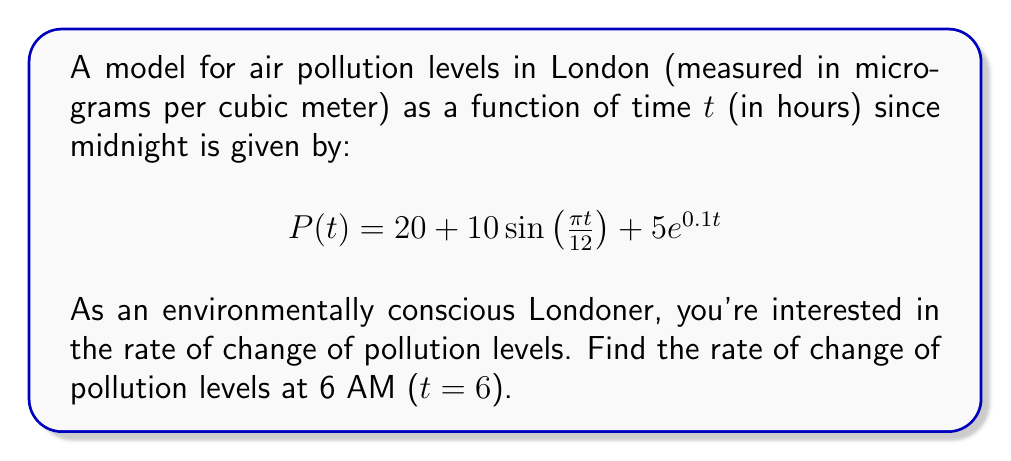Teach me how to tackle this problem. To find the rate of change of pollution levels at 6 AM, we need to find the derivative of P(t) and evaluate it at t = 6.

Step 1: Find P'(t) using the sum rule and chain rule.

$$P'(t) = \frac{d}{dt}[20 + 10\sin(\frac{\pi t}{12}) + 5e^{0.1t}]$$
$$P'(t) = 0 + 10\cos(\frac{\pi t}{12}) \cdot \frac{\pi}{12} + 5 \cdot 0.1e^{0.1t}$$
$$P'(t) = \frac{5\pi}{6}\cos(\frac{\pi t}{12}) + 0.5e^{0.1t}$$

Step 2: Evaluate P'(t) at t = 6.

$$P'(6) = \frac{5\pi}{6}\cos(\frac{\pi \cdot 6}{12}) + 0.5e^{0.1 \cdot 6}$$
$$P'(6) = \frac{5\pi}{6}\cos(\frac{\pi}{2}) + 0.5e^{0.6}$$

Step 3: Simplify.
Note that $\cos(\frac{\pi}{2}) = 0$, so the first term becomes zero.

$$P'(6) = 0 + 0.5e^{0.6} \approx 0.9108$$

The rate of change of pollution levels at 6 AM is approximately 0.9108 micrograms per cubic meter per hour.
Answer: $0.9108$ μg/m³/hour 